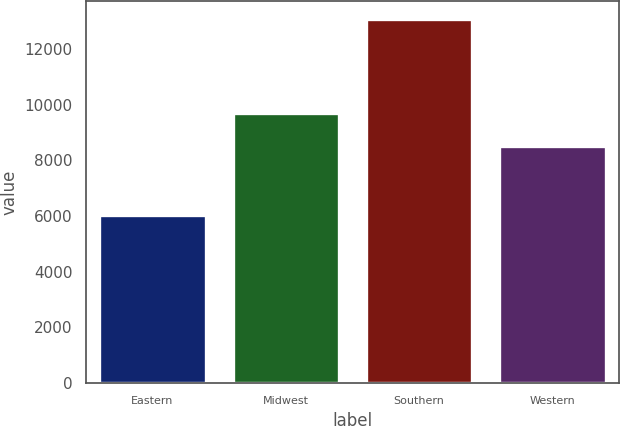Convert chart to OTSL. <chart><loc_0><loc_0><loc_500><loc_500><bar_chart><fcel>Eastern<fcel>Midwest<fcel>Southern<fcel>Western<nl><fcel>6047<fcel>9692<fcel>13078<fcel>8531<nl></chart> 